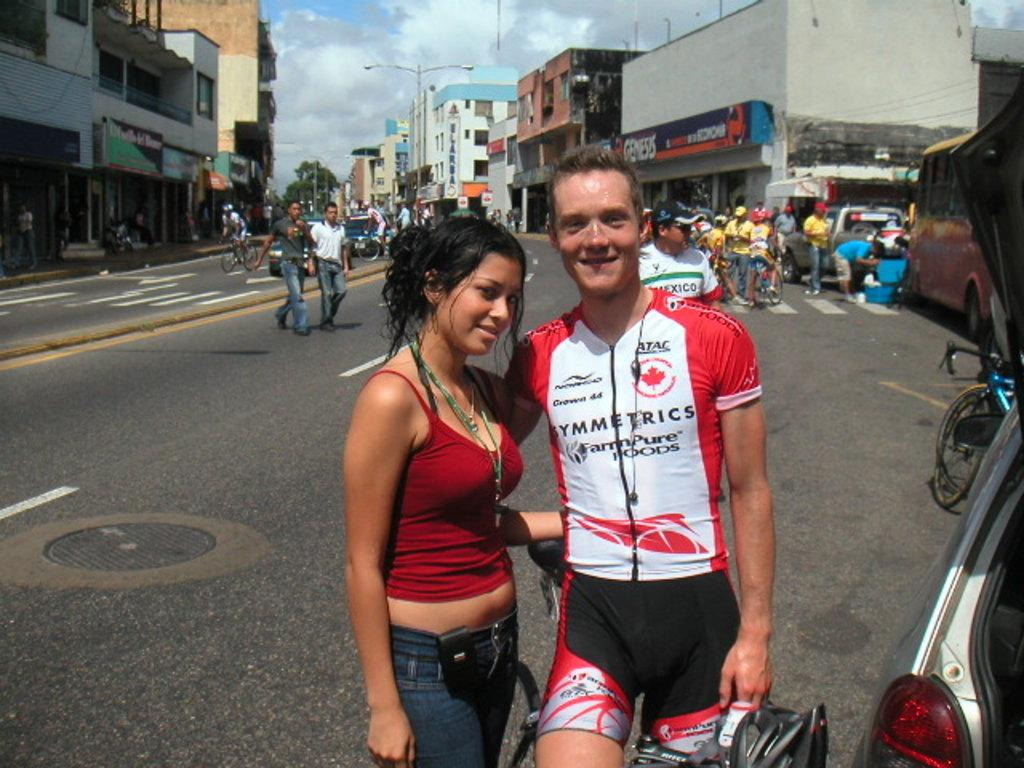How many people are present in the image? There are two people, a woman and a man, present in the image. What are the woman and man doing in the image? The woman and man are standing together in the image. What can be seen in the background of the image? There are buildings, people riding vehicles, street lights, clouds, trees, and vehicles visible in the background of the image. What part of the natural environment is visible in the image? The sky is visible in the background of the image. What type of jelly can be seen on the woman's face in the image? There is no jelly present on the woman's face in the image. What direction are the people riding vehicles moving in the background of the image? The image does not provide information about the direction in which the people riding vehicles are moving. 